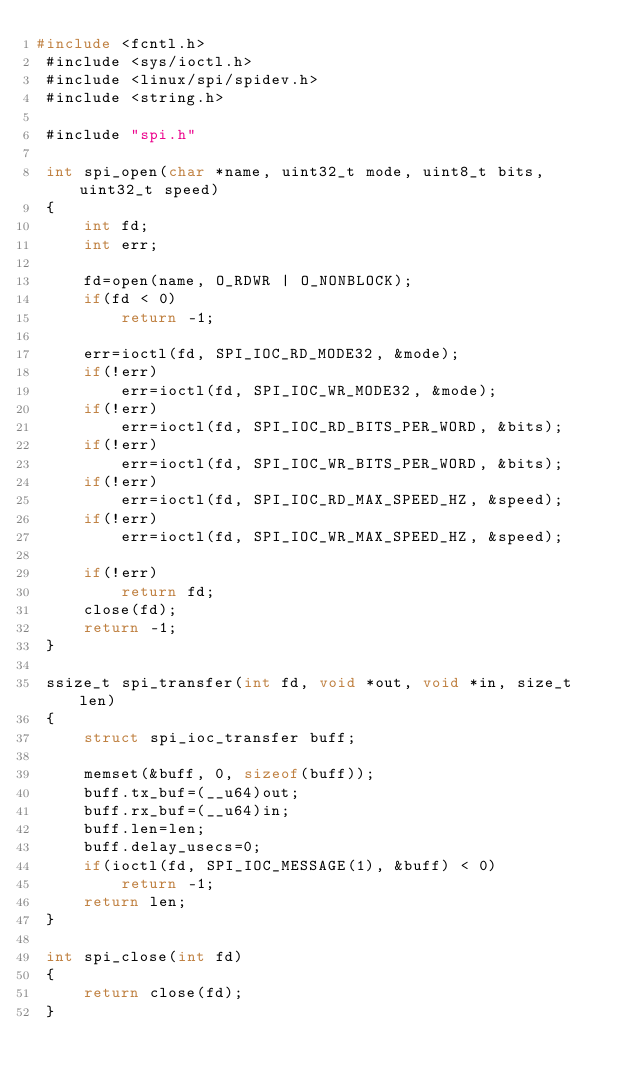<code> <loc_0><loc_0><loc_500><loc_500><_C_>#include <fcntl.h>
 #include <sys/ioctl.h>
 #include <linux/spi/spidev.h>
 #include <string.h>
 
 #include "spi.h"
 
 int spi_open(char *name, uint32_t mode, uint8_t bits, uint32_t speed)
 {
     int fd;
     int err;
 
     fd=open(name, O_RDWR | O_NONBLOCK);
     if(fd < 0)
         return -1;
 
     err=ioctl(fd, SPI_IOC_RD_MODE32, &mode);
     if(!err)
         err=ioctl(fd, SPI_IOC_WR_MODE32, &mode);
     if(!err)
         err=ioctl(fd, SPI_IOC_RD_BITS_PER_WORD, &bits);
     if(!err)
         err=ioctl(fd, SPI_IOC_WR_BITS_PER_WORD, &bits);
     if(!err)
         err=ioctl(fd, SPI_IOC_RD_MAX_SPEED_HZ, &speed);
     if(!err)
         err=ioctl(fd, SPI_IOC_WR_MAX_SPEED_HZ, &speed);
 
     if(!err)
         return fd;
     close(fd);
     return -1;
 }
 
 ssize_t spi_transfer(int fd, void *out, void *in, size_t len)
 {
     struct spi_ioc_transfer buff;
 
     memset(&buff, 0, sizeof(buff));
     buff.tx_buf=(__u64)out;
     buff.rx_buf=(__u64)in;
     buff.len=len;
     buff.delay_usecs=0;
     if(ioctl(fd, SPI_IOC_MESSAGE(1), &buff) < 0)
         return -1;
     return len;
 }
 
 int spi_close(int fd)
 {
     return close(fd);
 }</code> 